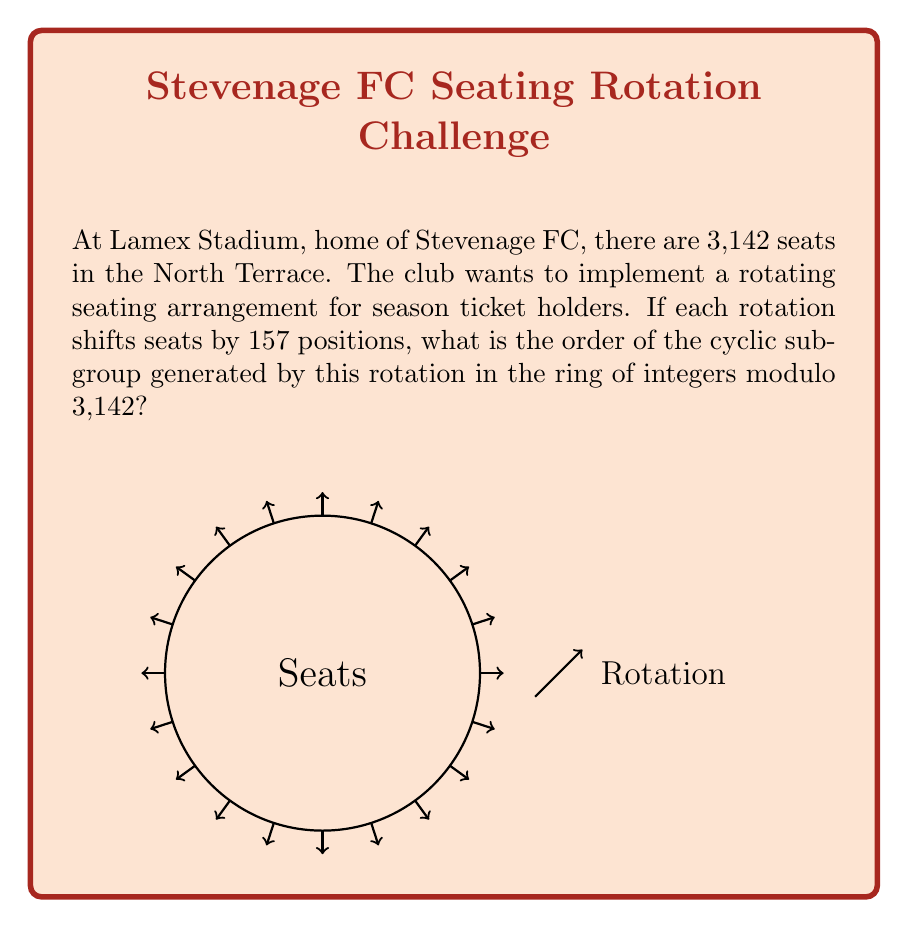What is the answer to this math problem? To solve this problem, we need to follow these steps:

1) First, we recognize that we're working in the ring $\mathbb{Z}_{3142}$ (integers modulo 3142).

2) The rotation is represented by the element 157 in this ring.

3) We need to find the order of the cyclic subgroup generated by 157, which is equivalent to finding the smallest positive integer $n$ such that:

   $157n \equiv 0 \pmod{3142}$

4) This is equivalent to finding the smallest positive integer $n$ such that 3142 divides $157n$.

5) In other words, we need to find the least common multiple (LCM) of 157 and 3142, divided by 157:

   $n = \frac{LCM(157, 3142)}{157}$

6) To find the LCM, we first need the greatest common divisor (GCD):

   $GCD(157, 3142) = 1$ (They are coprime)

7) Now we can calculate the LCM:

   $LCM(157, 3142) = \frac{157 \cdot 3142}{GCD(157, 3142)} = \frac{157 \cdot 3142}{1} = 493294$

8) Therefore, the order of the subgroup is:

   $n = \frac{493294}{157} = 3142$

This means that after 3142 rotations, every seat will return to its original position.
Answer: 3142 